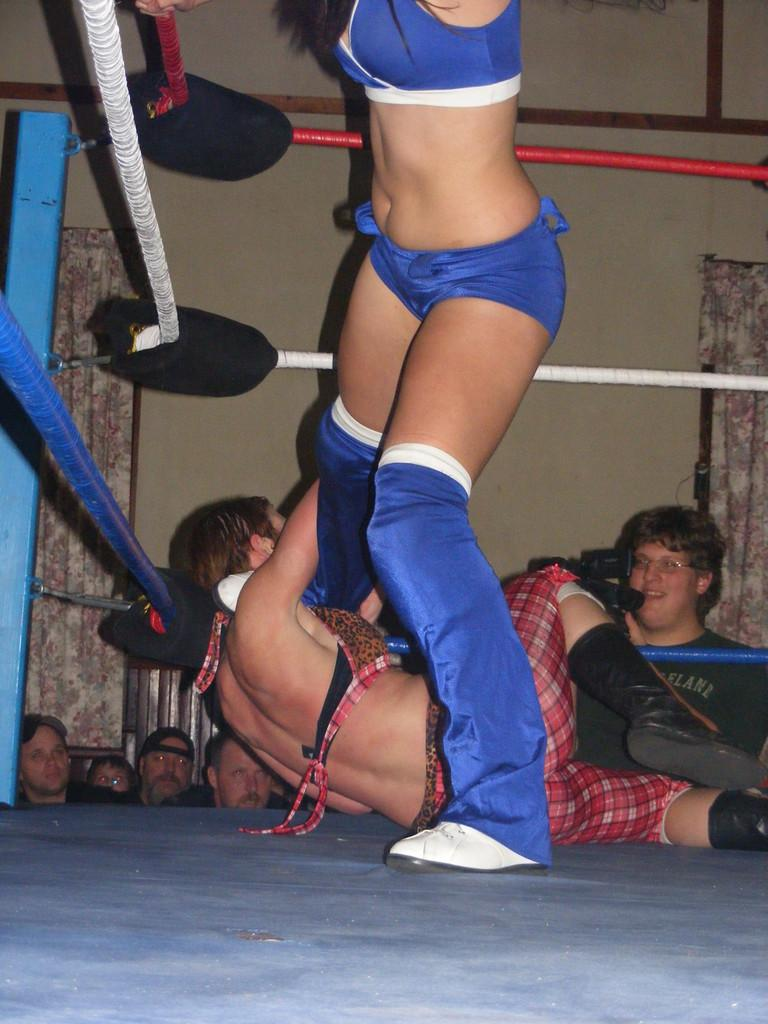What are the two people in the image doing? The two people are fighting in a ring. Who is observing the fight in the image? There is a group of persons behind the fighters. What can be seen in the background of the image? There is a wall visible in the background, and there are curtains as well. Can you describe the person on the right side of the image? Yes, a person is holding a video cam on the right side. What is the smell like in the image? The image does not provide any information about the smell, as it is a visual medium. 